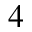Convert formula to latex. <formula><loc_0><loc_0><loc_500><loc_500>^ { 4 }</formula> 